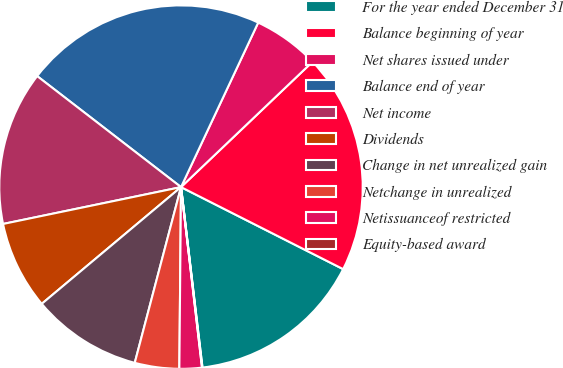Convert chart. <chart><loc_0><loc_0><loc_500><loc_500><pie_chart><fcel>For the year ended December 31<fcel>Balance beginning of year<fcel>Net shares issued under<fcel>Balance end of year<fcel>Net income<fcel>Dividends<fcel>Change in net unrealized gain<fcel>Netchange in unrealized<fcel>Netissuanceof restricted<fcel>Equity-based award<nl><fcel>15.66%<fcel>19.57%<fcel>5.9%<fcel>21.52%<fcel>13.71%<fcel>7.85%<fcel>9.8%<fcel>3.95%<fcel>1.99%<fcel>0.04%<nl></chart> 